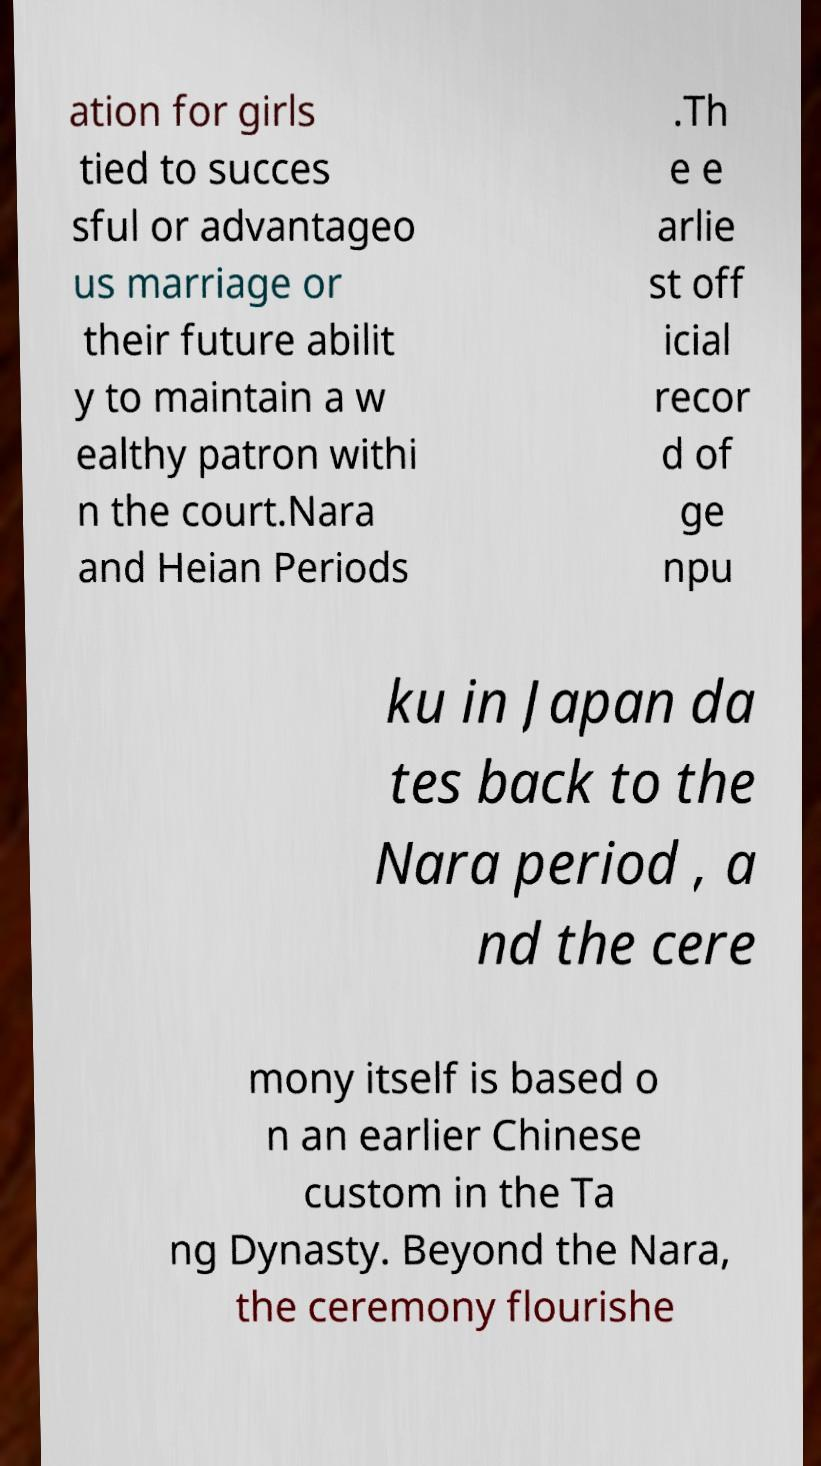Please read and relay the text visible in this image. What does it say? ation for girls tied to succes sful or advantageo us marriage or their future abilit y to maintain a w ealthy patron withi n the court.Nara and Heian Periods .Th e e arlie st off icial recor d of ge npu ku in Japan da tes back to the Nara period , a nd the cere mony itself is based o n an earlier Chinese custom in the Ta ng Dynasty. Beyond the Nara, the ceremony flourishe 